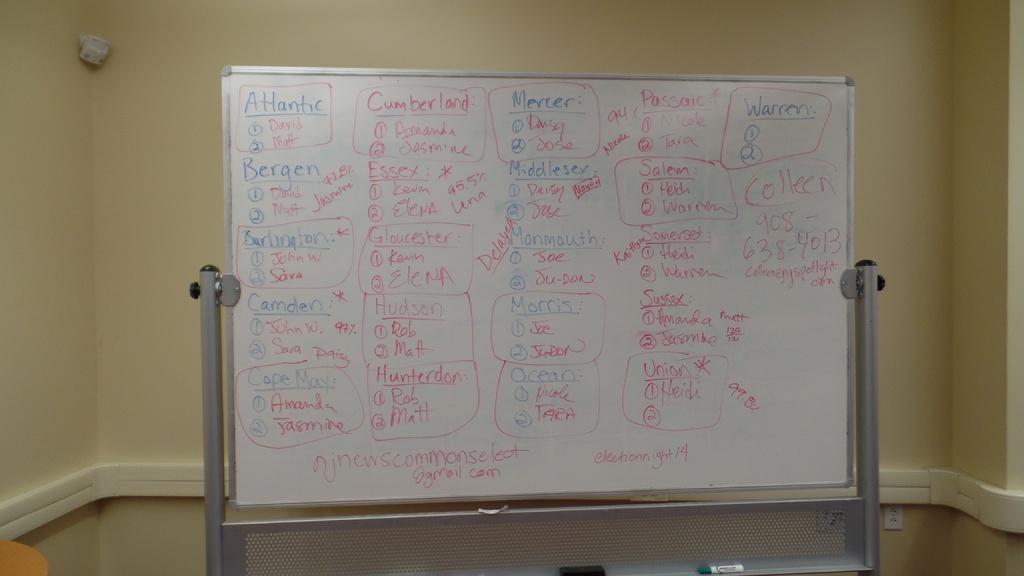What first word on the top left corner?
Provide a short and direct response. Atlantic. What email is writteno n the board?
Your response must be concise. Njnewscommonselect@gmail.com. 